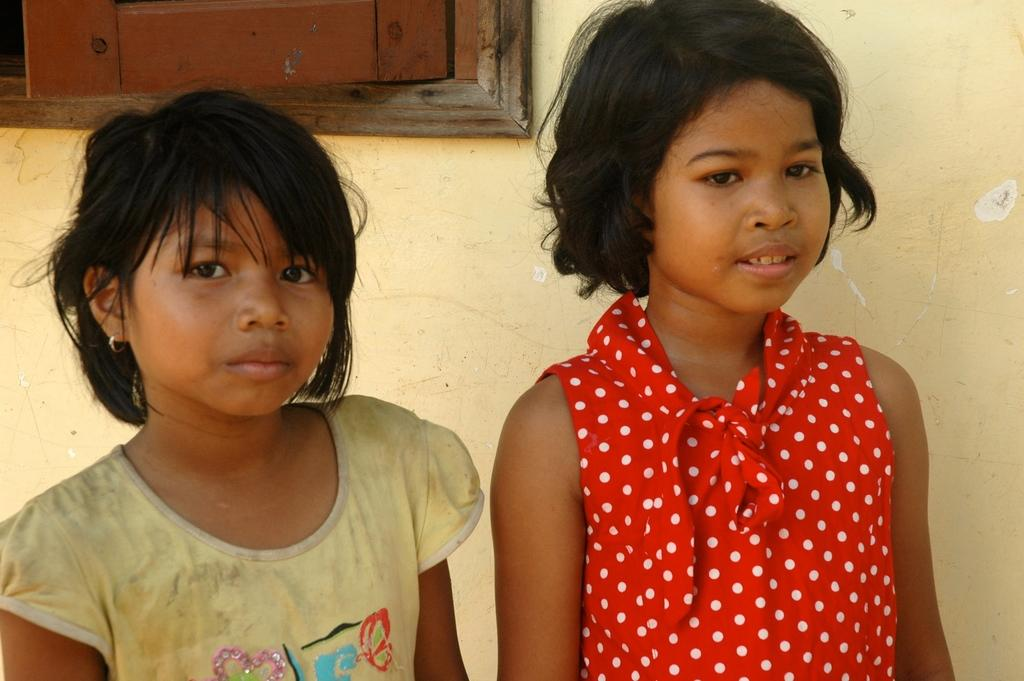How many people are in the image? There are two girls in the image. What are the girls doing in the image? The girls are standing and smiling. What can be seen behind the girls? There is an object and a wall visible at the back of the girls. What type of underwear is the governor wearing in the image? There is no governor or underwear present in the image; it features two girls standing and smiling. 